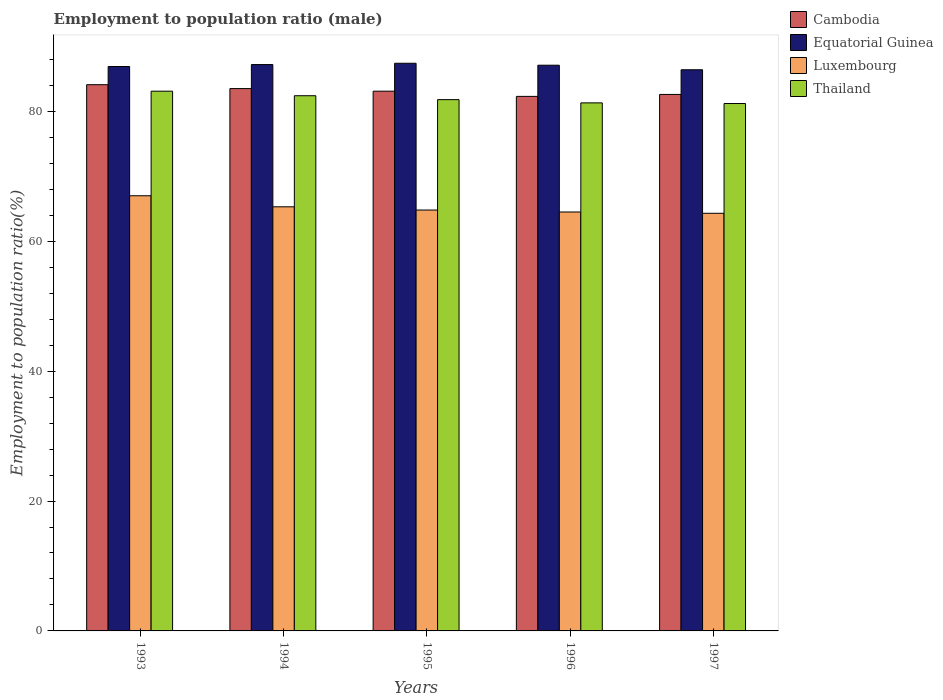How many different coloured bars are there?
Your answer should be compact. 4. How many groups of bars are there?
Your response must be concise. 5. Are the number of bars per tick equal to the number of legend labels?
Keep it short and to the point. Yes. How many bars are there on the 2nd tick from the left?
Provide a succinct answer. 4. How many bars are there on the 5th tick from the right?
Make the answer very short. 4. What is the label of the 5th group of bars from the left?
Your response must be concise. 1997. In how many cases, is the number of bars for a given year not equal to the number of legend labels?
Provide a short and direct response. 0. What is the employment to population ratio in Equatorial Guinea in 1997?
Ensure brevity in your answer.  86.4. Across all years, what is the maximum employment to population ratio in Luxembourg?
Make the answer very short. 67. Across all years, what is the minimum employment to population ratio in Equatorial Guinea?
Your answer should be compact. 86.4. What is the total employment to population ratio in Luxembourg in the graph?
Provide a succinct answer. 325.9. What is the difference between the employment to population ratio in Thailand in 1993 and that in 1996?
Your answer should be very brief. 1.8. What is the difference between the employment to population ratio in Thailand in 1994 and the employment to population ratio in Luxembourg in 1995?
Your response must be concise. 17.6. What is the average employment to population ratio in Cambodia per year?
Offer a very short reply. 83.12. In the year 1997, what is the difference between the employment to population ratio in Luxembourg and employment to population ratio in Cambodia?
Provide a succinct answer. -18.3. In how many years, is the employment to population ratio in Thailand greater than 40 %?
Your response must be concise. 5. What is the ratio of the employment to population ratio in Thailand in 1993 to that in 1994?
Offer a terse response. 1.01. Is the employment to population ratio in Thailand in 1993 less than that in 1996?
Provide a succinct answer. No. What is the difference between the highest and the second highest employment to population ratio in Thailand?
Offer a terse response. 0.7. What is the difference between the highest and the lowest employment to population ratio in Thailand?
Provide a succinct answer. 1.9. In how many years, is the employment to population ratio in Thailand greater than the average employment to population ratio in Thailand taken over all years?
Provide a succinct answer. 2. What does the 1st bar from the left in 1993 represents?
Your response must be concise. Cambodia. What does the 3rd bar from the right in 1995 represents?
Give a very brief answer. Equatorial Guinea. How many bars are there?
Offer a very short reply. 20. How many years are there in the graph?
Keep it short and to the point. 5. Are the values on the major ticks of Y-axis written in scientific E-notation?
Your answer should be compact. No. Does the graph contain any zero values?
Provide a short and direct response. No. Does the graph contain grids?
Your answer should be compact. No. Where does the legend appear in the graph?
Provide a succinct answer. Top right. What is the title of the graph?
Ensure brevity in your answer.  Employment to population ratio (male). Does "OECD members" appear as one of the legend labels in the graph?
Provide a short and direct response. No. What is the label or title of the X-axis?
Ensure brevity in your answer.  Years. What is the Employment to population ratio(%) in Cambodia in 1993?
Your response must be concise. 84.1. What is the Employment to population ratio(%) in Equatorial Guinea in 1993?
Your answer should be compact. 86.9. What is the Employment to population ratio(%) of Thailand in 1993?
Ensure brevity in your answer.  83.1. What is the Employment to population ratio(%) of Cambodia in 1994?
Provide a short and direct response. 83.5. What is the Employment to population ratio(%) in Equatorial Guinea in 1994?
Give a very brief answer. 87.2. What is the Employment to population ratio(%) in Luxembourg in 1994?
Make the answer very short. 65.3. What is the Employment to population ratio(%) of Thailand in 1994?
Provide a short and direct response. 82.4. What is the Employment to population ratio(%) in Cambodia in 1995?
Ensure brevity in your answer.  83.1. What is the Employment to population ratio(%) in Equatorial Guinea in 1995?
Give a very brief answer. 87.4. What is the Employment to population ratio(%) in Luxembourg in 1995?
Offer a very short reply. 64.8. What is the Employment to population ratio(%) in Thailand in 1995?
Make the answer very short. 81.8. What is the Employment to population ratio(%) of Cambodia in 1996?
Your answer should be very brief. 82.3. What is the Employment to population ratio(%) of Equatorial Guinea in 1996?
Give a very brief answer. 87.1. What is the Employment to population ratio(%) in Luxembourg in 1996?
Your response must be concise. 64.5. What is the Employment to population ratio(%) in Thailand in 1996?
Provide a short and direct response. 81.3. What is the Employment to population ratio(%) of Cambodia in 1997?
Offer a very short reply. 82.6. What is the Employment to population ratio(%) of Equatorial Guinea in 1997?
Keep it short and to the point. 86.4. What is the Employment to population ratio(%) in Luxembourg in 1997?
Provide a succinct answer. 64.3. What is the Employment to population ratio(%) of Thailand in 1997?
Your response must be concise. 81.2. Across all years, what is the maximum Employment to population ratio(%) in Cambodia?
Your answer should be compact. 84.1. Across all years, what is the maximum Employment to population ratio(%) in Equatorial Guinea?
Keep it short and to the point. 87.4. Across all years, what is the maximum Employment to population ratio(%) in Luxembourg?
Ensure brevity in your answer.  67. Across all years, what is the maximum Employment to population ratio(%) of Thailand?
Your answer should be compact. 83.1. Across all years, what is the minimum Employment to population ratio(%) in Cambodia?
Offer a very short reply. 82.3. Across all years, what is the minimum Employment to population ratio(%) of Equatorial Guinea?
Ensure brevity in your answer.  86.4. Across all years, what is the minimum Employment to population ratio(%) in Luxembourg?
Make the answer very short. 64.3. Across all years, what is the minimum Employment to population ratio(%) of Thailand?
Your answer should be very brief. 81.2. What is the total Employment to population ratio(%) in Cambodia in the graph?
Keep it short and to the point. 415.6. What is the total Employment to population ratio(%) of Equatorial Guinea in the graph?
Keep it short and to the point. 435. What is the total Employment to population ratio(%) of Luxembourg in the graph?
Give a very brief answer. 325.9. What is the total Employment to population ratio(%) of Thailand in the graph?
Your answer should be compact. 409.8. What is the difference between the Employment to population ratio(%) in Cambodia in 1993 and that in 1994?
Ensure brevity in your answer.  0.6. What is the difference between the Employment to population ratio(%) in Thailand in 1993 and that in 1994?
Your response must be concise. 0.7. What is the difference between the Employment to population ratio(%) of Cambodia in 1993 and that in 1995?
Provide a short and direct response. 1. What is the difference between the Employment to population ratio(%) of Equatorial Guinea in 1993 and that in 1995?
Ensure brevity in your answer.  -0.5. What is the difference between the Employment to population ratio(%) of Luxembourg in 1993 and that in 1995?
Keep it short and to the point. 2.2. What is the difference between the Employment to population ratio(%) of Luxembourg in 1993 and that in 1996?
Your answer should be very brief. 2.5. What is the difference between the Employment to population ratio(%) in Thailand in 1993 and that in 1996?
Make the answer very short. 1.8. What is the difference between the Employment to population ratio(%) in Cambodia in 1993 and that in 1997?
Provide a succinct answer. 1.5. What is the difference between the Employment to population ratio(%) in Luxembourg in 1993 and that in 1997?
Provide a succinct answer. 2.7. What is the difference between the Employment to population ratio(%) of Thailand in 1993 and that in 1997?
Give a very brief answer. 1.9. What is the difference between the Employment to population ratio(%) of Cambodia in 1994 and that in 1995?
Offer a very short reply. 0.4. What is the difference between the Employment to population ratio(%) of Luxembourg in 1994 and that in 1995?
Offer a very short reply. 0.5. What is the difference between the Employment to population ratio(%) in Cambodia in 1994 and that in 1996?
Offer a terse response. 1.2. What is the difference between the Employment to population ratio(%) of Thailand in 1995 and that in 1996?
Give a very brief answer. 0.5. What is the difference between the Employment to population ratio(%) of Cambodia in 1995 and that in 1997?
Provide a succinct answer. 0.5. What is the difference between the Employment to population ratio(%) in Equatorial Guinea in 1995 and that in 1997?
Ensure brevity in your answer.  1. What is the difference between the Employment to population ratio(%) in Luxembourg in 1995 and that in 1997?
Your answer should be very brief. 0.5. What is the difference between the Employment to population ratio(%) in Equatorial Guinea in 1996 and that in 1997?
Your response must be concise. 0.7. What is the difference between the Employment to population ratio(%) of Luxembourg in 1996 and that in 1997?
Your answer should be compact. 0.2. What is the difference between the Employment to population ratio(%) in Thailand in 1996 and that in 1997?
Ensure brevity in your answer.  0.1. What is the difference between the Employment to population ratio(%) in Cambodia in 1993 and the Employment to population ratio(%) in Thailand in 1994?
Make the answer very short. 1.7. What is the difference between the Employment to population ratio(%) of Equatorial Guinea in 1993 and the Employment to population ratio(%) of Luxembourg in 1994?
Give a very brief answer. 21.6. What is the difference between the Employment to population ratio(%) of Equatorial Guinea in 1993 and the Employment to population ratio(%) of Thailand in 1994?
Your answer should be compact. 4.5. What is the difference between the Employment to population ratio(%) of Luxembourg in 1993 and the Employment to population ratio(%) of Thailand in 1994?
Keep it short and to the point. -15.4. What is the difference between the Employment to population ratio(%) of Cambodia in 1993 and the Employment to population ratio(%) of Luxembourg in 1995?
Provide a succinct answer. 19.3. What is the difference between the Employment to population ratio(%) of Cambodia in 1993 and the Employment to population ratio(%) of Thailand in 1995?
Offer a very short reply. 2.3. What is the difference between the Employment to population ratio(%) of Equatorial Guinea in 1993 and the Employment to population ratio(%) of Luxembourg in 1995?
Offer a terse response. 22.1. What is the difference between the Employment to population ratio(%) in Equatorial Guinea in 1993 and the Employment to population ratio(%) in Thailand in 1995?
Keep it short and to the point. 5.1. What is the difference between the Employment to population ratio(%) in Luxembourg in 1993 and the Employment to population ratio(%) in Thailand in 1995?
Offer a terse response. -14.8. What is the difference between the Employment to population ratio(%) in Cambodia in 1993 and the Employment to population ratio(%) in Equatorial Guinea in 1996?
Offer a very short reply. -3. What is the difference between the Employment to population ratio(%) of Cambodia in 1993 and the Employment to population ratio(%) of Luxembourg in 1996?
Your response must be concise. 19.6. What is the difference between the Employment to population ratio(%) of Equatorial Guinea in 1993 and the Employment to population ratio(%) of Luxembourg in 1996?
Give a very brief answer. 22.4. What is the difference between the Employment to population ratio(%) in Luxembourg in 1993 and the Employment to population ratio(%) in Thailand in 1996?
Ensure brevity in your answer.  -14.3. What is the difference between the Employment to population ratio(%) of Cambodia in 1993 and the Employment to population ratio(%) of Luxembourg in 1997?
Give a very brief answer. 19.8. What is the difference between the Employment to population ratio(%) of Equatorial Guinea in 1993 and the Employment to population ratio(%) of Luxembourg in 1997?
Your response must be concise. 22.6. What is the difference between the Employment to population ratio(%) in Equatorial Guinea in 1993 and the Employment to population ratio(%) in Thailand in 1997?
Keep it short and to the point. 5.7. What is the difference between the Employment to population ratio(%) in Cambodia in 1994 and the Employment to population ratio(%) in Luxembourg in 1995?
Give a very brief answer. 18.7. What is the difference between the Employment to population ratio(%) of Equatorial Guinea in 1994 and the Employment to population ratio(%) of Luxembourg in 1995?
Your response must be concise. 22.4. What is the difference between the Employment to population ratio(%) in Luxembourg in 1994 and the Employment to population ratio(%) in Thailand in 1995?
Provide a succinct answer. -16.5. What is the difference between the Employment to population ratio(%) in Cambodia in 1994 and the Employment to population ratio(%) in Equatorial Guinea in 1996?
Offer a terse response. -3.6. What is the difference between the Employment to population ratio(%) in Equatorial Guinea in 1994 and the Employment to population ratio(%) in Luxembourg in 1996?
Your response must be concise. 22.7. What is the difference between the Employment to population ratio(%) in Equatorial Guinea in 1994 and the Employment to population ratio(%) in Thailand in 1996?
Give a very brief answer. 5.9. What is the difference between the Employment to population ratio(%) of Cambodia in 1994 and the Employment to population ratio(%) of Equatorial Guinea in 1997?
Provide a succinct answer. -2.9. What is the difference between the Employment to population ratio(%) in Cambodia in 1994 and the Employment to population ratio(%) in Thailand in 1997?
Keep it short and to the point. 2.3. What is the difference between the Employment to population ratio(%) in Equatorial Guinea in 1994 and the Employment to population ratio(%) in Luxembourg in 1997?
Offer a terse response. 22.9. What is the difference between the Employment to population ratio(%) of Equatorial Guinea in 1994 and the Employment to population ratio(%) of Thailand in 1997?
Give a very brief answer. 6. What is the difference between the Employment to population ratio(%) in Luxembourg in 1994 and the Employment to population ratio(%) in Thailand in 1997?
Give a very brief answer. -15.9. What is the difference between the Employment to population ratio(%) of Cambodia in 1995 and the Employment to population ratio(%) of Equatorial Guinea in 1996?
Keep it short and to the point. -4. What is the difference between the Employment to population ratio(%) in Cambodia in 1995 and the Employment to population ratio(%) in Thailand in 1996?
Make the answer very short. 1.8. What is the difference between the Employment to population ratio(%) in Equatorial Guinea in 1995 and the Employment to population ratio(%) in Luxembourg in 1996?
Your answer should be very brief. 22.9. What is the difference between the Employment to population ratio(%) of Luxembourg in 1995 and the Employment to population ratio(%) of Thailand in 1996?
Provide a succinct answer. -16.5. What is the difference between the Employment to population ratio(%) in Cambodia in 1995 and the Employment to population ratio(%) in Luxembourg in 1997?
Make the answer very short. 18.8. What is the difference between the Employment to population ratio(%) in Equatorial Guinea in 1995 and the Employment to population ratio(%) in Luxembourg in 1997?
Your response must be concise. 23.1. What is the difference between the Employment to population ratio(%) of Luxembourg in 1995 and the Employment to population ratio(%) of Thailand in 1997?
Your answer should be compact. -16.4. What is the difference between the Employment to population ratio(%) in Cambodia in 1996 and the Employment to population ratio(%) in Equatorial Guinea in 1997?
Make the answer very short. -4.1. What is the difference between the Employment to population ratio(%) of Equatorial Guinea in 1996 and the Employment to population ratio(%) of Luxembourg in 1997?
Ensure brevity in your answer.  22.8. What is the difference between the Employment to population ratio(%) in Luxembourg in 1996 and the Employment to population ratio(%) in Thailand in 1997?
Provide a succinct answer. -16.7. What is the average Employment to population ratio(%) in Cambodia per year?
Offer a terse response. 83.12. What is the average Employment to population ratio(%) of Equatorial Guinea per year?
Offer a terse response. 87. What is the average Employment to population ratio(%) of Luxembourg per year?
Provide a short and direct response. 65.18. What is the average Employment to population ratio(%) of Thailand per year?
Your answer should be very brief. 81.96. In the year 1993, what is the difference between the Employment to population ratio(%) of Cambodia and Employment to population ratio(%) of Luxembourg?
Offer a terse response. 17.1. In the year 1993, what is the difference between the Employment to population ratio(%) in Cambodia and Employment to population ratio(%) in Thailand?
Provide a succinct answer. 1. In the year 1993, what is the difference between the Employment to population ratio(%) in Luxembourg and Employment to population ratio(%) in Thailand?
Provide a short and direct response. -16.1. In the year 1994, what is the difference between the Employment to population ratio(%) of Equatorial Guinea and Employment to population ratio(%) of Luxembourg?
Make the answer very short. 21.9. In the year 1994, what is the difference between the Employment to population ratio(%) in Luxembourg and Employment to population ratio(%) in Thailand?
Offer a very short reply. -17.1. In the year 1995, what is the difference between the Employment to population ratio(%) in Equatorial Guinea and Employment to population ratio(%) in Luxembourg?
Give a very brief answer. 22.6. In the year 1996, what is the difference between the Employment to population ratio(%) of Equatorial Guinea and Employment to population ratio(%) of Luxembourg?
Your answer should be compact. 22.6. In the year 1996, what is the difference between the Employment to population ratio(%) of Luxembourg and Employment to population ratio(%) of Thailand?
Keep it short and to the point. -16.8. In the year 1997, what is the difference between the Employment to population ratio(%) of Cambodia and Employment to population ratio(%) of Luxembourg?
Give a very brief answer. 18.3. In the year 1997, what is the difference between the Employment to population ratio(%) of Cambodia and Employment to population ratio(%) of Thailand?
Make the answer very short. 1.4. In the year 1997, what is the difference between the Employment to population ratio(%) of Equatorial Guinea and Employment to population ratio(%) of Luxembourg?
Provide a succinct answer. 22.1. In the year 1997, what is the difference between the Employment to population ratio(%) in Equatorial Guinea and Employment to population ratio(%) in Thailand?
Keep it short and to the point. 5.2. In the year 1997, what is the difference between the Employment to population ratio(%) of Luxembourg and Employment to population ratio(%) of Thailand?
Provide a succinct answer. -16.9. What is the ratio of the Employment to population ratio(%) of Thailand in 1993 to that in 1994?
Keep it short and to the point. 1.01. What is the ratio of the Employment to population ratio(%) of Luxembourg in 1993 to that in 1995?
Your response must be concise. 1.03. What is the ratio of the Employment to population ratio(%) in Thailand in 1993 to that in 1995?
Provide a short and direct response. 1.02. What is the ratio of the Employment to population ratio(%) in Cambodia in 1993 to that in 1996?
Provide a short and direct response. 1.02. What is the ratio of the Employment to population ratio(%) of Equatorial Guinea in 1993 to that in 1996?
Keep it short and to the point. 1. What is the ratio of the Employment to population ratio(%) of Luxembourg in 1993 to that in 1996?
Give a very brief answer. 1.04. What is the ratio of the Employment to population ratio(%) of Thailand in 1993 to that in 1996?
Your answer should be compact. 1.02. What is the ratio of the Employment to population ratio(%) of Cambodia in 1993 to that in 1997?
Give a very brief answer. 1.02. What is the ratio of the Employment to population ratio(%) in Equatorial Guinea in 1993 to that in 1997?
Provide a short and direct response. 1.01. What is the ratio of the Employment to population ratio(%) of Luxembourg in 1993 to that in 1997?
Keep it short and to the point. 1.04. What is the ratio of the Employment to population ratio(%) in Thailand in 1993 to that in 1997?
Your answer should be very brief. 1.02. What is the ratio of the Employment to population ratio(%) in Luxembourg in 1994 to that in 1995?
Provide a short and direct response. 1.01. What is the ratio of the Employment to population ratio(%) of Thailand in 1994 to that in 1995?
Offer a very short reply. 1.01. What is the ratio of the Employment to population ratio(%) of Cambodia in 1994 to that in 1996?
Your answer should be compact. 1.01. What is the ratio of the Employment to population ratio(%) of Luxembourg in 1994 to that in 1996?
Offer a terse response. 1.01. What is the ratio of the Employment to population ratio(%) of Thailand in 1994 to that in 1996?
Ensure brevity in your answer.  1.01. What is the ratio of the Employment to population ratio(%) of Cambodia in 1994 to that in 1997?
Make the answer very short. 1.01. What is the ratio of the Employment to population ratio(%) of Equatorial Guinea in 1994 to that in 1997?
Give a very brief answer. 1.01. What is the ratio of the Employment to population ratio(%) in Luxembourg in 1994 to that in 1997?
Provide a succinct answer. 1.02. What is the ratio of the Employment to population ratio(%) of Thailand in 1994 to that in 1997?
Your answer should be compact. 1.01. What is the ratio of the Employment to population ratio(%) in Cambodia in 1995 to that in 1996?
Ensure brevity in your answer.  1.01. What is the ratio of the Employment to population ratio(%) in Luxembourg in 1995 to that in 1996?
Your response must be concise. 1. What is the ratio of the Employment to population ratio(%) in Cambodia in 1995 to that in 1997?
Ensure brevity in your answer.  1.01. What is the ratio of the Employment to population ratio(%) of Equatorial Guinea in 1995 to that in 1997?
Your answer should be compact. 1.01. What is the ratio of the Employment to population ratio(%) of Thailand in 1995 to that in 1997?
Provide a short and direct response. 1.01. What is the ratio of the Employment to population ratio(%) in Equatorial Guinea in 1996 to that in 1997?
Make the answer very short. 1.01. What is the ratio of the Employment to population ratio(%) of Luxembourg in 1996 to that in 1997?
Your answer should be very brief. 1. What is the ratio of the Employment to population ratio(%) of Thailand in 1996 to that in 1997?
Your answer should be very brief. 1. What is the difference between the highest and the second highest Employment to population ratio(%) in Cambodia?
Your answer should be compact. 0.6. What is the difference between the highest and the second highest Employment to population ratio(%) in Equatorial Guinea?
Give a very brief answer. 0.2. What is the difference between the highest and the second highest Employment to population ratio(%) of Luxembourg?
Your response must be concise. 1.7. What is the difference between the highest and the second highest Employment to population ratio(%) of Thailand?
Give a very brief answer. 0.7. What is the difference between the highest and the lowest Employment to population ratio(%) of Equatorial Guinea?
Your response must be concise. 1. What is the difference between the highest and the lowest Employment to population ratio(%) in Luxembourg?
Your answer should be very brief. 2.7. What is the difference between the highest and the lowest Employment to population ratio(%) in Thailand?
Provide a succinct answer. 1.9. 